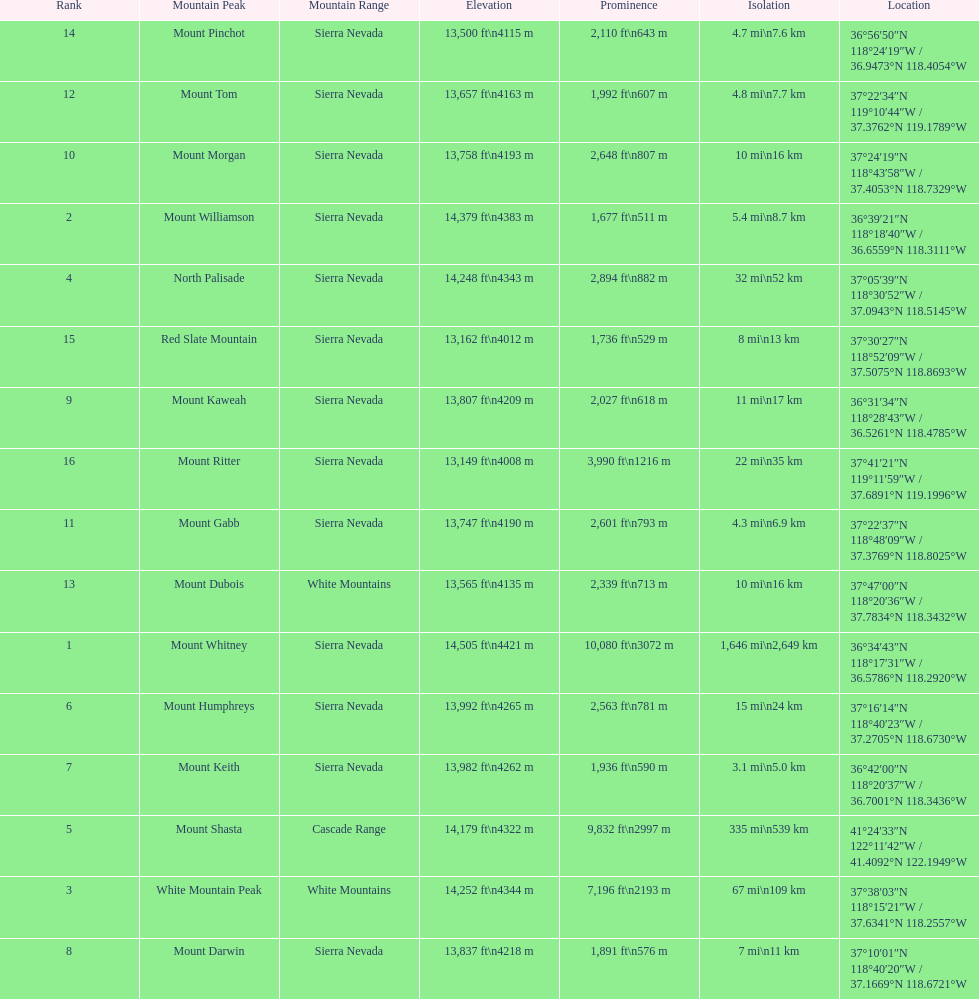What is the total elevation (in ft) of mount whitney? 14,505 ft. 